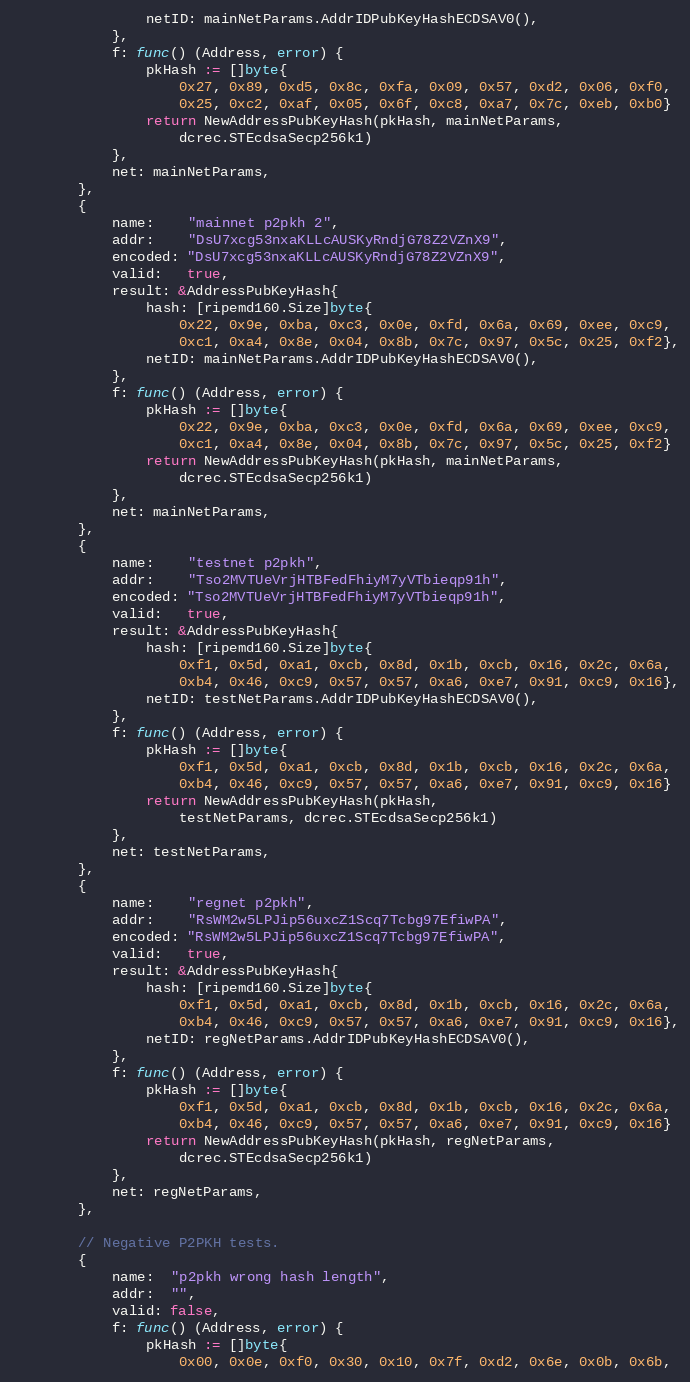Convert code to text. <code><loc_0><loc_0><loc_500><loc_500><_Go_>				netID: mainNetParams.AddrIDPubKeyHashECDSAV0(),
			},
			f: func() (Address, error) {
				pkHash := []byte{
					0x27, 0x89, 0xd5, 0x8c, 0xfa, 0x09, 0x57, 0xd2, 0x06, 0xf0,
					0x25, 0xc2, 0xaf, 0x05, 0x6f, 0xc8, 0xa7, 0x7c, 0xeb, 0xb0}
				return NewAddressPubKeyHash(pkHash, mainNetParams,
					dcrec.STEcdsaSecp256k1)
			},
			net: mainNetParams,
		},
		{
			name:    "mainnet p2pkh 2",
			addr:    "DsU7xcg53nxaKLLcAUSKyRndjG78Z2VZnX9",
			encoded: "DsU7xcg53nxaKLLcAUSKyRndjG78Z2VZnX9",
			valid:   true,
			result: &AddressPubKeyHash{
				hash: [ripemd160.Size]byte{
					0x22, 0x9e, 0xba, 0xc3, 0x0e, 0xfd, 0x6a, 0x69, 0xee, 0xc9,
					0xc1, 0xa4, 0x8e, 0x04, 0x8b, 0x7c, 0x97, 0x5c, 0x25, 0xf2},
				netID: mainNetParams.AddrIDPubKeyHashECDSAV0(),
			},
			f: func() (Address, error) {
				pkHash := []byte{
					0x22, 0x9e, 0xba, 0xc3, 0x0e, 0xfd, 0x6a, 0x69, 0xee, 0xc9,
					0xc1, 0xa4, 0x8e, 0x04, 0x8b, 0x7c, 0x97, 0x5c, 0x25, 0xf2}
				return NewAddressPubKeyHash(pkHash, mainNetParams,
					dcrec.STEcdsaSecp256k1)
			},
			net: mainNetParams,
		},
		{
			name:    "testnet p2pkh",
			addr:    "Tso2MVTUeVrjHTBFedFhiyM7yVTbieqp91h",
			encoded: "Tso2MVTUeVrjHTBFedFhiyM7yVTbieqp91h",
			valid:   true,
			result: &AddressPubKeyHash{
				hash: [ripemd160.Size]byte{
					0xf1, 0x5d, 0xa1, 0xcb, 0x8d, 0x1b, 0xcb, 0x16, 0x2c, 0x6a,
					0xb4, 0x46, 0xc9, 0x57, 0x57, 0xa6, 0xe7, 0x91, 0xc9, 0x16},
				netID: testNetParams.AddrIDPubKeyHashECDSAV0(),
			},
			f: func() (Address, error) {
				pkHash := []byte{
					0xf1, 0x5d, 0xa1, 0xcb, 0x8d, 0x1b, 0xcb, 0x16, 0x2c, 0x6a,
					0xb4, 0x46, 0xc9, 0x57, 0x57, 0xa6, 0xe7, 0x91, 0xc9, 0x16}
				return NewAddressPubKeyHash(pkHash,
					testNetParams, dcrec.STEcdsaSecp256k1)
			},
			net: testNetParams,
		},
		{
			name:    "regnet p2pkh",
			addr:    "RsWM2w5LPJip56uxcZ1Scq7Tcbg97EfiwPA",
			encoded: "RsWM2w5LPJip56uxcZ1Scq7Tcbg97EfiwPA",
			valid:   true,
			result: &AddressPubKeyHash{
				hash: [ripemd160.Size]byte{
					0xf1, 0x5d, 0xa1, 0xcb, 0x8d, 0x1b, 0xcb, 0x16, 0x2c, 0x6a,
					0xb4, 0x46, 0xc9, 0x57, 0x57, 0xa6, 0xe7, 0x91, 0xc9, 0x16},
				netID: regNetParams.AddrIDPubKeyHashECDSAV0(),
			},
			f: func() (Address, error) {
				pkHash := []byte{
					0xf1, 0x5d, 0xa1, 0xcb, 0x8d, 0x1b, 0xcb, 0x16, 0x2c, 0x6a,
					0xb4, 0x46, 0xc9, 0x57, 0x57, 0xa6, 0xe7, 0x91, 0xc9, 0x16}
				return NewAddressPubKeyHash(pkHash, regNetParams,
					dcrec.STEcdsaSecp256k1)
			},
			net: regNetParams,
		},

		// Negative P2PKH tests.
		{
			name:  "p2pkh wrong hash length",
			addr:  "",
			valid: false,
			f: func() (Address, error) {
				pkHash := []byte{
					0x00, 0x0e, 0xf0, 0x30, 0x10, 0x7f, 0xd2, 0x6e, 0x0b, 0x6b,</code> 